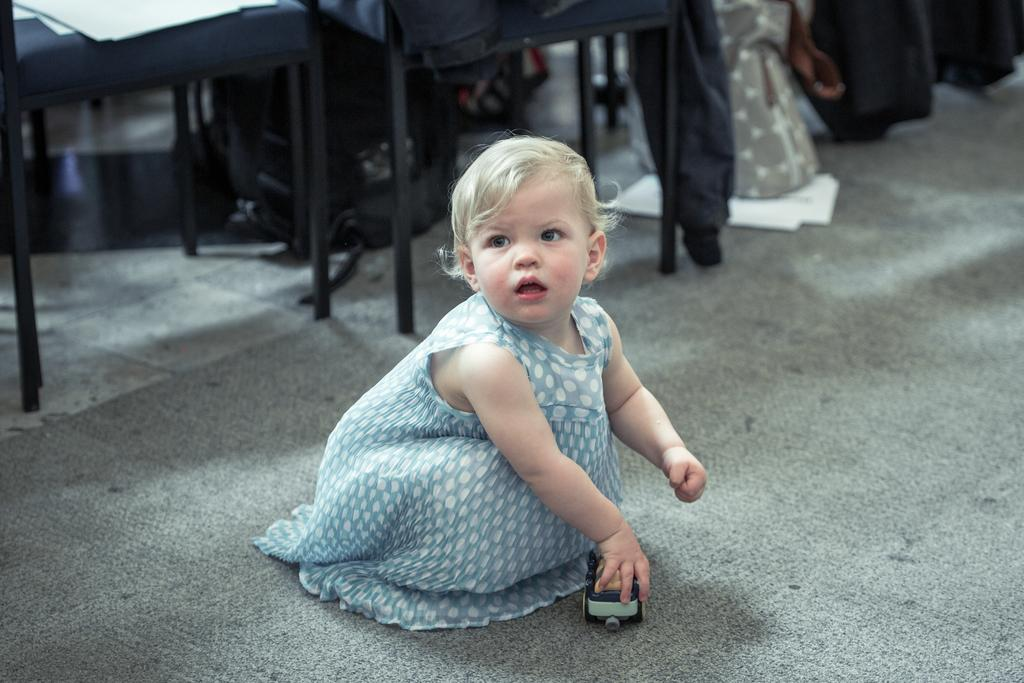Who is the main subject in the image? There is a girl in the image. What is the girl doing in the image? The girl is sitting on the ground. What is the girl holding in her hand? The girl is holding a toy in her hand. What can be seen behind the girl in the image? There are chairs visible behind the girl. What type of mark is the girl making on the ground with a hammer in the image? There is no hammer or mark-making activity present in the image. 